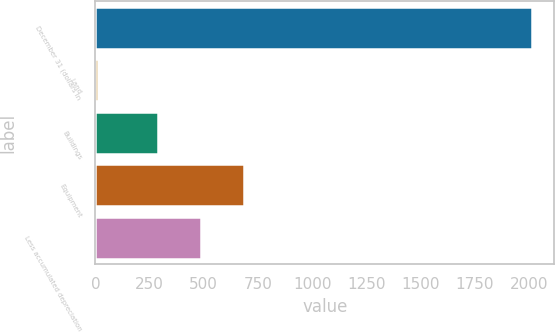Convert chart. <chart><loc_0><loc_0><loc_500><loc_500><bar_chart><fcel>December 31 (dollars in<fcel>Land<fcel>Buildings<fcel>Equipment<fcel>Less accumulated depreciation<nl><fcel>2016<fcel>11<fcel>286.4<fcel>687.4<fcel>486.9<nl></chart> 